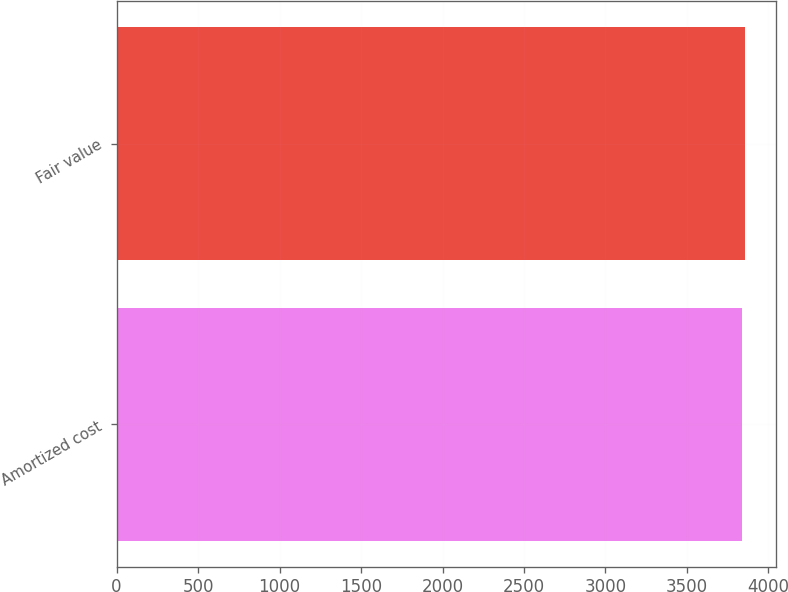<chart> <loc_0><loc_0><loc_500><loc_500><bar_chart><fcel>Amortized cost<fcel>Fair value<nl><fcel>3837<fcel>3853<nl></chart> 